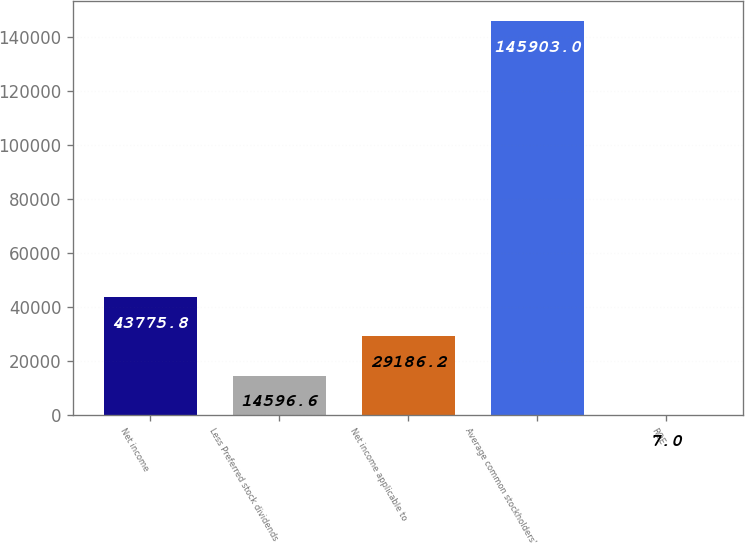<chart> <loc_0><loc_0><loc_500><loc_500><bar_chart><fcel>Net income<fcel>Less Preferred stock dividends<fcel>Net income applicable to<fcel>Average common stockholders'<fcel>ROE<nl><fcel>43775.8<fcel>14596.6<fcel>29186.2<fcel>145903<fcel>7<nl></chart> 